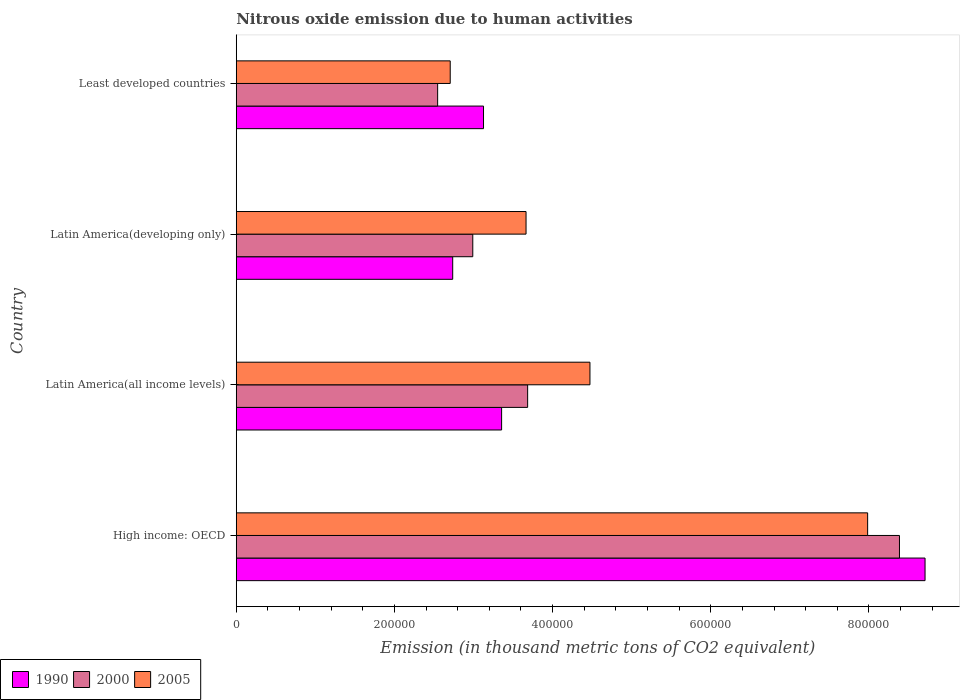Are the number of bars per tick equal to the number of legend labels?
Your answer should be very brief. Yes. How many bars are there on the 1st tick from the bottom?
Provide a short and direct response. 3. What is the label of the 2nd group of bars from the top?
Offer a terse response. Latin America(developing only). What is the amount of nitrous oxide emitted in 2000 in Latin America(all income levels)?
Give a very brief answer. 3.68e+05. Across all countries, what is the maximum amount of nitrous oxide emitted in 2000?
Give a very brief answer. 8.39e+05. Across all countries, what is the minimum amount of nitrous oxide emitted in 2000?
Your answer should be compact. 2.55e+05. In which country was the amount of nitrous oxide emitted in 2000 maximum?
Provide a succinct answer. High income: OECD. In which country was the amount of nitrous oxide emitted in 2005 minimum?
Your answer should be compact. Least developed countries. What is the total amount of nitrous oxide emitted in 2000 in the graph?
Ensure brevity in your answer.  1.76e+06. What is the difference between the amount of nitrous oxide emitted in 2005 in Latin America(developing only) and that in Least developed countries?
Provide a succinct answer. 9.59e+04. What is the difference between the amount of nitrous oxide emitted in 2005 in Latin America(developing only) and the amount of nitrous oxide emitted in 1990 in Least developed countries?
Give a very brief answer. 5.38e+04. What is the average amount of nitrous oxide emitted in 1990 per country?
Provide a short and direct response. 4.48e+05. What is the difference between the amount of nitrous oxide emitted in 2000 and amount of nitrous oxide emitted in 1990 in High income: OECD?
Make the answer very short. -3.24e+04. In how many countries, is the amount of nitrous oxide emitted in 2000 greater than 120000 thousand metric tons?
Ensure brevity in your answer.  4. What is the ratio of the amount of nitrous oxide emitted in 1990 in High income: OECD to that in Latin America(developing only)?
Make the answer very short. 3.18. Is the difference between the amount of nitrous oxide emitted in 2000 in Latin America(all income levels) and Least developed countries greater than the difference between the amount of nitrous oxide emitted in 1990 in Latin America(all income levels) and Least developed countries?
Ensure brevity in your answer.  Yes. What is the difference between the highest and the second highest amount of nitrous oxide emitted in 2005?
Give a very brief answer. 3.51e+05. What is the difference between the highest and the lowest amount of nitrous oxide emitted in 2005?
Offer a terse response. 5.28e+05. Is the sum of the amount of nitrous oxide emitted in 2005 in Latin America(all income levels) and Least developed countries greater than the maximum amount of nitrous oxide emitted in 2000 across all countries?
Give a very brief answer. No. What does the 1st bar from the bottom in Latin America(developing only) represents?
Your answer should be very brief. 1990. Is it the case that in every country, the sum of the amount of nitrous oxide emitted in 1990 and amount of nitrous oxide emitted in 2005 is greater than the amount of nitrous oxide emitted in 2000?
Give a very brief answer. Yes. How many bars are there?
Your response must be concise. 12. How many countries are there in the graph?
Make the answer very short. 4. What is the difference between two consecutive major ticks on the X-axis?
Your answer should be compact. 2.00e+05. Are the values on the major ticks of X-axis written in scientific E-notation?
Make the answer very short. No. Does the graph contain grids?
Your answer should be very brief. No. How are the legend labels stacked?
Provide a succinct answer. Horizontal. What is the title of the graph?
Your response must be concise. Nitrous oxide emission due to human activities. What is the label or title of the X-axis?
Keep it short and to the point. Emission (in thousand metric tons of CO2 equivalent). What is the Emission (in thousand metric tons of CO2 equivalent) of 1990 in High income: OECD?
Make the answer very short. 8.71e+05. What is the Emission (in thousand metric tons of CO2 equivalent) of 2000 in High income: OECD?
Offer a very short reply. 8.39e+05. What is the Emission (in thousand metric tons of CO2 equivalent) of 2005 in High income: OECD?
Ensure brevity in your answer.  7.98e+05. What is the Emission (in thousand metric tons of CO2 equivalent) of 1990 in Latin America(all income levels)?
Ensure brevity in your answer.  3.36e+05. What is the Emission (in thousand metric tons of CO2 equivalent) of 2000 in Latin America(all income levels)?
Make the answer very short. 3.68e+05. What is the Emission (in thousand metric tons of CO2 equivalent) in 2005 in Latin America(all income levels)?
Offer a very short reply. 4.47e+05. What is the Emission (in thousand metric tons of CO2 equivalent) in 1990 in Latin America(developing only)?
Ensure brevity in your answer.  2.74e+05. What is the Emission (in thousand metric tons of CO2 equivalent) of 2000 in Latin America(developing only)?
Your answer should be very brief. 2.99e+05. What is the Emission (in thousand metric tons of CO2 equivalent) in 2005 in Latin America(developing only)?
Offer a very short reply. 3.66e+05. What is the Emission (in thousand metric tons of CO2 equivalent) in 1990 in Least developed countries?
Offer a very short reply. 3.13e+05. What is the Emission (in thousand metric tons of CO2 equivalent) of 2000 in Least developed countries?
Make the answer very short. 2.55e+05. What is the Emission (in thousand metric tons of CO2 equivalent) in 2005 in Least developed countries?
Your answer should be compact. 2.71e+05. Across all countries, what is the maximum Emission (in thousand metric tons of CO2 equivalent) of 1990?
Provide a short and direct response. 8.71e+05. Across all countries, what is the maximum Emission (in thousand metric tons of CO2 equivalent) of 2000?
Your response must be concise. 8.39e+05. Across all countries, what is the maximum Emission (in thousand metric tons of CO2 equivalent) of 2005?
Offer a very short reply. 7.98e+05. Across all countries, what is the minimum Emission (in thousand metric tons of CO2 equivalent) in 1990?
Ensure brevity in your answer.  2.74e+05. Across all countries, what is the minimum Emission (in thousand metric tons of CO2 equivalent) of 2000?
Ensure brevity in your answer.  2.55e+05. Across all countries, what is the minimum Emission (in thousand metric tons of CO2 equivalent) in 2005?
Offer a very short reply. 2.71e+05. What is the total Emission (in thousand metric tons of CO2 equivalent) in 1990 in the graph?
Your answer should be compact. 1.79e+06. What is the total Emission (in thousand metric tons of CO2 equivalent) in 2000 in the graph?
Make the answer very short. 1.76e+06. What is the total Emission (in thousand metric tons of CO2 equivalent) in 2005 in the graph?
Ensure brevity in your answer.  1.88e+06. What is the difference between the Emission (in thousand metric tons of CO2 equivalent) in 1990 in High income: OECD and that in Latin America(all income levels)?
Give a very brief answer. 5.35e+05. What is the difference between the Emission (in thousand metric tons of CO2 equivalent) of 2000 in High income: OECD and that in Latin America(all income levels)?
Provide a succinct answer. 4.70e+05. What is the difference between the Emission (in thousand metric tons of CO2 equivalent) in 2005 in High income: OECD and that in Latin America(all income levels)?
Give a very brief answer. 3.51e+05. What is the difference between the Emission (in thousand metric tons of CO2 equivalent) in 1990 in High income: OECD and that in Latin America(developing only)?
Your answer should be compact. 5.97e+05. What is the difference between the Emission (in thousand metric tons of CO2 equivalent) in 2000 in High income: OECD and that in Latin America(developing only)?
Offer a very short reply. 5.40e+05. What is the difference between the Emission (in thousand metric tons of CO2 equivalent) in 2005 in High income: OECD and that in Latin America(developing only)?
Make the answer very short. 4.32e+05. What is the difference between the Emission (in thousand metric tons of CO2 equivalent) of 1990 in High income: OECD and that in Least developed countries?
Keep it short and to the point. 5.58e+05. What is the difference between the Emission (in thousand metric tons of CO2 equivalent) in 2000 in High income: OECD and that in Least developed countries?
Offer a very short reply. 5.84e+05. What is the difference between the Emission (in thousand metric tons of CO2 equivalent) of 2005 in High income: OECD and that in Least developed countries?
Your response must be concise. 5.28e+05. What is the difference between the Emission (in thousand metric tons of CO2 equivalent) in 1990 in Latin America(all income levels) and that in Latin America(developing only)?
Keep it short and to the point. 6.18e+04. What is the difference between the Emission (in thousand metric tons of CO2 equivalent) in 2000 in Latin America(all income levels) and that in Latin America(developing only)?
Make the answer very short. 6.94e+04. What is the difference between the Emission (in thousand metric tons of CO2 equivalent) of 2005 in Latin America(all income levels) and that in Latin America(developing only)?
Offer a terse response. 8.08e+04. What is the difference between the Emission (in thousand metric tons of CO2 equivalent) of 1990 in Latin America(all income levels) and that in Least developed countries?
Make the answer very short. 2.29e+04. What is the difference between the Emission (in thousand metric tons of CO2 equivalent) in 2000 in Latin America(all income levels) and that in Least developed countries?
Keep it short and to the point. 1.14e+05. What is the difference between the Emission (in thousand metric tons of CO2 equivalent) in 2005 in Latin America(all income levels) and that in Least developed countries?
Give a very brief answer. 1.77e+05. What is the difference between the Emission (in thousand metric tons of CO2 equivalent) in 1990 in Latin America(developing only) and that in Least developed countries?
Your answer should be very brief. -3.90e+04. What is the difference between the Emission (in thousand metric tons of CO2 equivalent) of 2000 in Latin America(developing only) and that in Least developed countries?
Your answer should be very brief. 4.44e+04. What is the difference between the Emission (in thousand metric tons of CO2 equivalent) of 2005 in Latin America(developing only) and that in Least developed countries?
Give a very brief answer. 9.59e+04. What is the difference between the Emission (in thousand metric tons of CO2 equivalent) of 1990 in High income: OECD and the Emission (in thousand metric tons of CO2 equivalent) of 2000 in Latin America(all income levels)?
Give a very brief answer. 5.03e+05. What is the difference between the Emission (in thousand metric tons of CO2 equivalent) of 1990 in High income: OECD and the Emission (in thousand metric tons of CO2 equivalent) of 2005 in Latin America(all income levels)?
Ensure brevity in your answer.  4.24e+05. What is the difference between the Emission (in thousand metric tons of CO2 equivalent) of 2000 in High income: OECD and the Emission (in thousand metric tons of CO2 equivalent) of 2005 in Latin America(all income levels)?
Provide a succinct answer. 3.91e+05. What is the difference between the Emission (in thousand metric tons of CO2 equivalent) in 1990 in High income: OECD and the Emission (in thousand metric tons of CO2 equivalent) in 2000 in Latin America(developing only)?
Ensure brevity in your answer.  5.72e+05. What is the difference between the Emission (in thousand metric tons of CO2 equivalent) of 1990 in High income: OECD and the Emission (in thousand metric tons of CO2 equivalent) of 2005 in Latin America(developing only)?
Offer a very short reply. 5.05e+05. What is the difference between the Emission (in thousand metric tons of CO2 equivalent) in 2000 in High income: OECD and the Emission (in thousand metric tons of CO2 equivalent) in 2005 in Latin America(developing only)?
Offer a terse response. 4.72e+05. What is the difference between the Emission (in thousand metric tons of CO2 equivalent) of 1990 in High income: OECD and the Emission (in thousand metric tons of CO2 equivalent) of 2000 in Least developed countries?
Provide a short and direct response. 6.16e+05. What is the difference between the Emission (in thousand metric tons of CO2 equivalent) of 1990 in High income: OECD and the Emission (in thousand metric tons of CO2 equivalent) of 2005 in Least developed countries?
Provide a short and direct response. 6.00e+05. What is the difference between the Emission (in thousand metric tons of CO2 equivalent) of 2000 in High income: OECD and the Emission (in thousand metric tons of CO2 equivalent) of 2005 in Least developed countries?
Ensure brevity in your answer.  5.68e+05. What is the difference between the Emission (in thousand metric tons of CO2 equivalent) in 1990 in Latin America(all income levels) and the Emission (in thousand metric tons of CO2 equivalent) in 2000 in Latin America(developing only)?
Offer a very short reply. 3.65e+04. What is the difference between the Emission (in thousand metric tons of CO2 equivalent) in 1990 in Latin America(all income levels) and the Emission (in thousand metric tons of CO2 equivalent) in 2005 in Latin America(developing only)?
Provide a short and direct response. -3.09e+04. What is the difference between the Emission (in thousand metric tons of CO2 equivalent) of 2000 in Latin America(all income levels) and the Emission (in thousand metric tons of CO2 equivalent) of 2005 in Latin America(developing only)?
Give a very brief answer. 2012. What is the difference between the Emission (in thousand metric tons of CO2 equivalent) in 1990 in Latin America(all income levels) and the Emission (in thousand metric tons of CO2 equivalent) in 2000 in Least developed countries?
Your answer should be very brief. 8.09e+04. What is the difference between the Emission (in thousand metric tons of CO2 equivalent) of 1990 in Latin America(all income levels) and the Emission (in thousand metric tons of CO2 equivalent) of 2005 in Least developed countries?
Make the answer very short. 6.50e+04. What is the difference between the Emission (in thousand metric tons of CO2 equivalent) in 2000 in Latin America(all income levels) and the Emission (in thousand metric tons of CO2 equivalent) in 2005 in Least developed countries?
Your answer should be compact. 9.79e+04. What is the difference between the Emission (in thousand metric tons of CO2 equivalent) in 1990 in Latin America(developing only) and the Emission (in thousand metric tons of CO2 equivalent) in 2000 in Least developed countries?
Your answer should be very brief. 1.91e+04. What is the difference between the Emission (in thousand metric tons of CO2 equivalent) of 1990 in Latin America(developing only) and the Emission (in thousand metric tons of CO2 equivalent) of 2005 in Least developed countries?
Your answer should be compact. 3144.7. What is the difference between the Emission (in thousand metric tons of CO2 equivalent) in 2000 in Latin America(developing only) and the Emission (in thousand metric tons of CO2 equivalent) in 2005 in Least developed countries?
Your response must be concise. 2.85e+04. What is the average Emission (in thousand metric tons of CO2 equivalent) in 1990 per country?
Offer a terse response. 4.48e+05. What is the average Emission (in thousand metric tons of CO2 equivalent) in 2000 per country?
Your response must be concise. 4.40e+05. What is the average Emission (in thousand metric tons of CO2 equivalent) in 2005 per country?
Offer a terse response. 4.71e+05. What is the difference between the Emission (in thousand metric tons of CO2 equivalent) of 1990 and Emission (in thousand metric tons of CO2 equivalent) of 2000 in High income: OECD?
Offer a terse response. 3.24e+04. What is the difference between the Emission (in thousand metric tons of CO2 equivalent) in 1990 and Emission (in thousand metric tons of CO2 equivalent) in 2005 in High income: OECD?
Your answer should be very brief. 7.26e+04. What is the difference between the Emission (in thousand metric tons of CO2 equivalent) in 2000 and Emission (in thousand metric tons of CO2 equivalent) in 2005 in High income: OECD?
Offer a terse response. 4.02e+04. What is the difference between the Emission (in thousand metric tons of CO2 equivalent) of 1990 and Emission (in thousand metric tons of CO2 equivalent) of 2000 in Latin America(all income levels)?
Offer a terse response. -3.29e+04. What is the difference between the Emission (in thousand metric tons of CO2 equivalent) in 1990 and Emission (in thousand metric tons of CO2 equivalent) in 2005 in Latin America(all income levels)?
Offer a very short reply. -1.12e+05. What is the difference between the Emission (in thousand metric tons of CO2 equivalent) of 2000 and Emission (in thousand metric tons of CO2 equivalent) of 2005 in Latin America(all income levels)?
Provide a short and direct response. -7.88e+04. What is the difference between the Emission (in thousand metric tons of CO2 equivalent) of 1990 and Emission (in thousand metric tons of CO2 equivalent) of 2000 in Latin America(developing only)?
Your answer should be compact. -2.54e+04. What is the difference between the Emission (in thousand metric tons of CO2 equivalent) of 1990 and Emission (in thousand metric tons of CO2 equivalent) of 2005 in Latin America(developing only)?
Your answer should be compact. -9.27e+04. What is the difference between the Emission (in thousand metric tons of CO2 equivalent) in 2000 and Emission (in thousand metric tons of CO2 equivalent) in 2005 in Latin America(developing only)?
Provide a succinct answer. -6.74e+04. What is the difference between the Emission (in thousand metric tons of CO2 equivalent) of 1990 and Emission (in thousand metric tons of CO2 equivalent) of 2000 in Least developed countries?
Ensure brevity in your answer.  5.80e+04. What is the difference between the Emission (in thousand metric tons of CO2 equivalent) of 1990 and Emission (in thousand metric tons of CO2 equivalent) of 2005 in Least developed countries?
Your answer should be very brief. 4.21e+04. What is the difference between the Emission (in thousand metric tons of CO2 equivalent) in 2000 and Emission (in thousand metric tons of CO2 equivalent) in 2005 in Least developed countries?
Ensure brevity in your answer.  -1.59e+04. What is the ratio of the Emission (in thousand metric tons of CO2 equivalent) of 1990 in High income: OECD to that in Latin America(all income levels)?
Ensure brevity in your answer.  2.6. What is the ratio of the Emission (in thousand metric tons of CO2 equivalent) in 2000 in High income: OECD to that in Latin America(all income levels)?
Ensure brevity in your answer.  2.28. What is the ratio of the Emission (in thousand metric tons of CO2 equivalent) of 2005 in High income: OECD to that in Latin America(all income levels)?
Ensure brevity in your answer.  1.78. What is the ratio of the Emission (in thousand metric tons of CO2 equivalent) in 1990 in High income: OECD to that in Latin America(developing only)?
Provide a succinct answer. 3.18. What is the ratio of the Emission (in thousand metric tons of CO2 equivalent) in 2000 in High income: OECD to that in Latin America(developing only)?
Offer a terse response. 2.8. What is the ratio of the Emission (in thousand metric tons of CO2 equivalent) of 2005 in High income: OECD to that in Latin America(developing only)?
Give a very brief answer. 2.18. What is the ratio of the Emission (in thousand metric tons of CO2 equivalent) in 1990 in High income: OECD to that in Least developed countries?
Your response must be concise. 2.79. What is the ratio of the Emission (in thousand metric tons of CO2 equivalent) of 2000 in High income: OECD to that in Least developed countries?
Offer a terse response. 3.29. What is the ratio of the Emission (in thousand metric tons of CO2 equivalent) in 2005 in High income: OECD to that in Least developed countries?
Your answer should be very brief. 2.95. What is the ratio of the Emission (in thousand metric tons of CO2 equivalent) of 1990 in Latin America(all income levels) to that in Latin America(developing only)?
Keep it short and to the point. 1.23. What is the ratio of the Emission (in thousand metric tons of CO2 equivalent) in 2000 in Latin America(all income levels) to that in Latin America(developing only)?
Keep it short and to the point. 1.23. What is the ratio of the Emission (in thousand metric tons of CO2 equivalent) of 2005 in Latin America(all income levels) to that in Latin America(developing only)?
Your answer should be very brief. 1.22. What is the ratio of the Emission (in thousand metric tons of CO2 equivalent) in 1990 in Latin America(all income levels) to that in Least developed countries?
Give a very brief answer. 1.07. What is the ratio of the Emission (in thousand metric tons of CO2 equivalent) of 2000 in Latin America(all income levels) to that in Least developed countries?
Offer a terse response. 1.45. What is the ratio of the Emission (in thousand metric tons of CO2 equivalent) in 2005 in Latin America(all income levels) to that in Least developed countries?
Provide a succinct answer. 1.65. What is the ratio of the Emission (in thousand metric tons of CO2 equivalent) of 1990 in Latin America(developing only) to that in Least developed countries?
Your response must be concise. 0.88. What is the ratio of the Emission (in thousand metric tons of CO2 equivalent) of 2000 in Latin America(developing only) to that in Least developed countries?
Provide a succinct answer. 1.17. What is the ratio of the Emission (in thousand metric tons of CO2 equivalent) in 2005 in Latin America(developing only) to that in Least developed countries?
Your answer should be compact. 1.35. What is the difference between the highest and the second highest Emission (in thousand metric tons of CO2 equivalent) of 1990?
Your response must be concise. 5.35e+05. What is the difference between the highest and the second highest Emission (in thousand metric tons of CO2 equivalent) in 2000?
Ensure brevity in your answer.  4.70e+05. What is the difference between the highest and the second highest Emission (in thousand metric tons of CO2 equivalent) of 2005?
Give a very brief answer. 3.51e+05. What is the difference between the highest and the lowest Emission (in thousand metric tons of CO2 equivalent) of 1990?
Your response must be concise. 5.97e+05. What is the difference between the highest and the lowest Emission (in thousand metric tons of CO2 equivalent) in 2000?
Give a very brief answer. 5.84e+05. What is the difference between the highest and the lowest Emission (in thousand metric tons of CO2 equivalent) in 2005?
Offer a very short reply. 5.28e+05. 